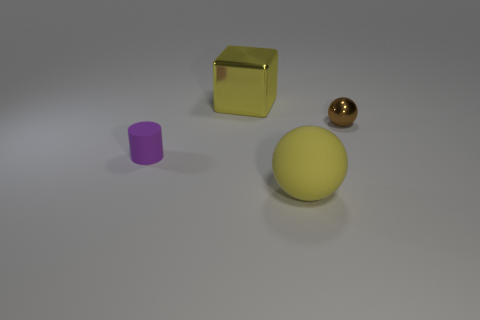There is a thing that is in front of the metallic ball and behind the matte sphere; what color is it?
Provide a succinct answer. Purple. Is there anything else that has the same color as the big matte thing?
Your answer should be compact. Yes. There is a matte object right of the object that is to the left of the cube; what is its color?
Your answer should be very brief. Yellow. Do the purple cylinder and the brown metal thing have the same size?
Offer a terse response. Yes. Does the big sphere in front of the big block have the same material as the tiny object that is to the left of the tiny shiny thing?
Provide a short and direct response. Yes. There is a yellow thing that is behind the small thing that is on the right side of the large yellow object that is in front of the yellow block; what shape is it?
Offer a terse response. Cube. Is the number of spheres greater than the number of objects?
Make the answer very short. No. Is there a tiny green thing?
Give a very brief answer. No. How many things are things that are behind the tiny purple rubber cylinder or tiny things that are to the right of the tiny purple matte cylinder?
Your response must be concise. 2. Is the cube the same color as the large sphere?
Ensure brevity in your answer.  Yes. 